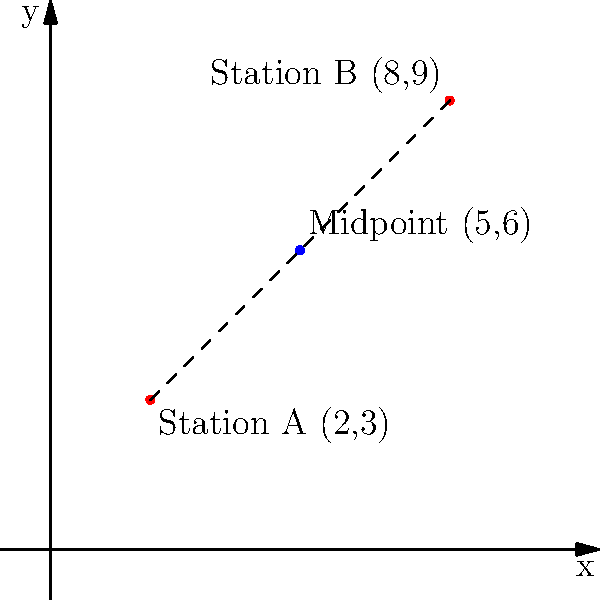Two ranger stations are located on a map with coordinates A(2,3) and B(8,9). To optimize emergency response times, you need to find the midpoint between these two stations. What are the coordinates of this midpoint? To find the midpoint between two points, we use the midpoint formula:

$$ \text{Midpoint} = (\frac{x_1 + x_2}{2}, \frac{y_1 + y_2}{2}) $$

Where $(x_1, y_1)$ are the coordinates of the first point and $(x_2, y_2)$ are the coordinates of the second point.

For our ranger stations:
Station A: $(x_1, y_1) = (2, 3)$
Station B: $(x_2, y_2) = (8, 9)$

Let's calculate the x-coordinate of the midpoint:
$$ x = \frac{x_1 + x_2}{2} = \frac{2 + 8}{2} = \frac{10}{2} = 5 $$

Now, let's calculate the y-coordinate of the midpoint:
$$ y = \frac{y_1 + y_2}{2} = \frac{3 + 9}{2} = \frac{12}{2} = 6 $$

Therefore, the coordinates of the midpoint are (5, 6).
Answer: (5, 6) 